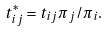<formula> <loc_0><loc_0><loc_500><loc_500>t ^ { * } _ { i j } = t _ { i j } \pi _ { j } / \pi _ { i } .</formula> 